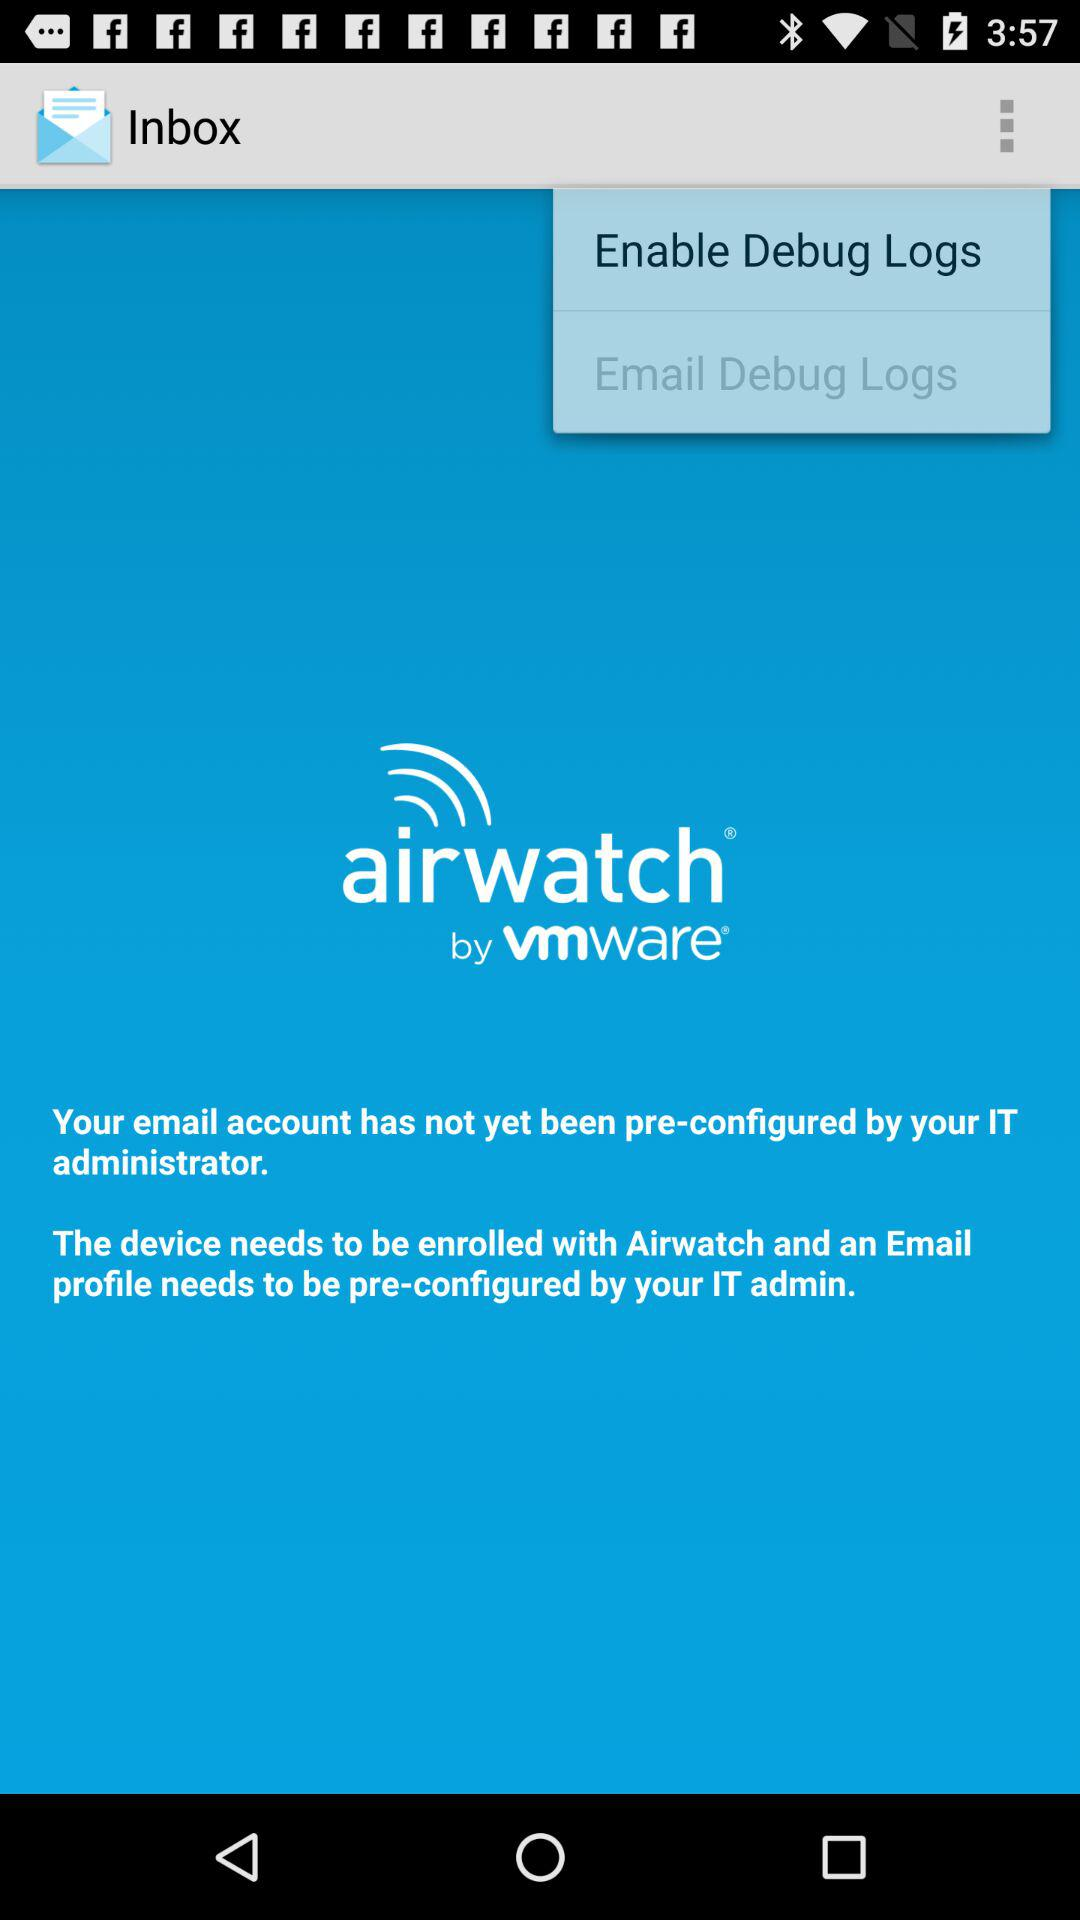What is the name of the application? The name of the application is "airwatch® by vmware®". 